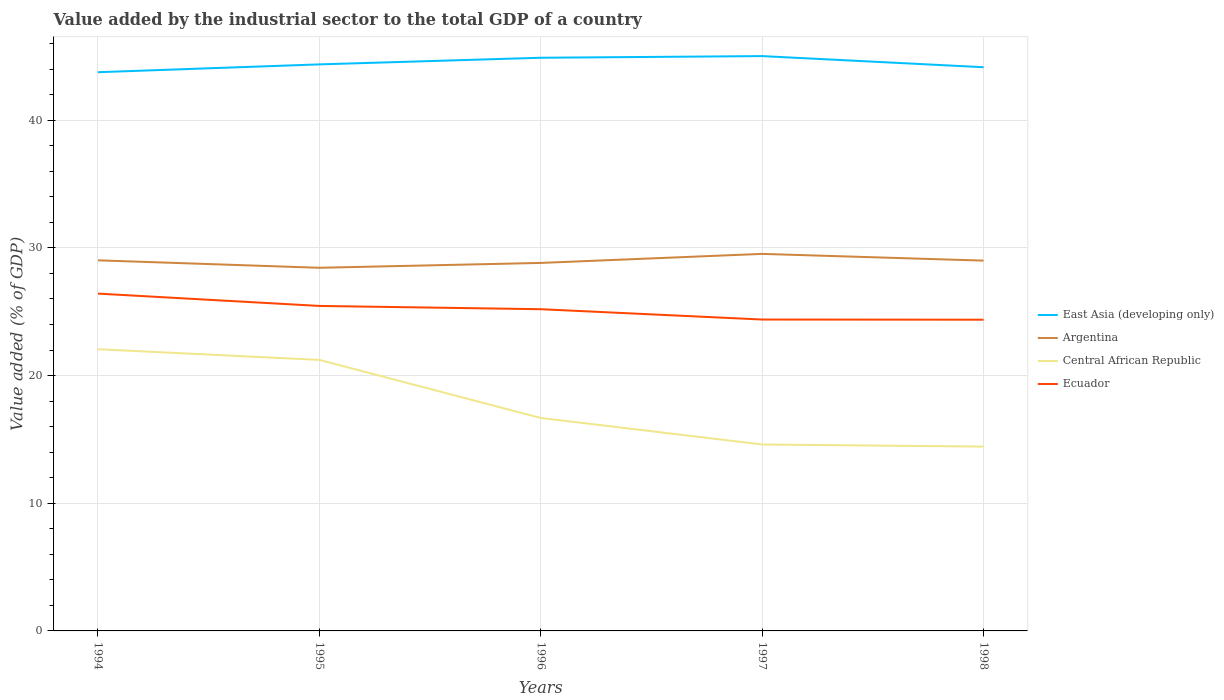Across all years, what is the maximum value added by the industrial sector to the total GDP in Argentina?
Provide a succinct answer. 28.44. In which year was the value added by the industrial sector to the total GDP in Central African Republic maximum?
Offer a terse response. 1998. What is the total value added by the industrial sector to the total GDP in Ecuador in the graph?
Your response must be concise. 1.22. What is the difference between the highest and the second highest value added by the industrial sector to the total GDP in Central African Republic?
Provide a short and direct response. 7.63. What is the difference between the highest and the lowest value added by the industrial sector to the total GDP in Ecuador?
Keep it short and to the point. 3. Does the graph contain grids?
Your response must be concise. Yes. Where does the legend appear in the graph?
Keep it short and to the point. Center right. How many legend labels are there?
Make the answer very short. 4. What is the title of the graph?
Make the answer very short. Value added by the industrial sector to the total GDP of a country. Does "South Sudan" appear as one of the legend labels in the graph?
Your answer should be very brief. No. What is the label or title of the X-axis?
Your response must be concise. Years. What is the label or title of the Y-axis?
Offer a very short reply. Value added (% of GDP). What is the Value added (% of GDP) in East Asia (developing only) in 1994?
Offer a very short reply. 43.76. What is the Value added (% of GDP) of Argentina in 1994?
Give a very brief answer. 29.02. What is the Value added (% of GDP) in Central African Republic in 1994?
Your response must be concise. 22.06. What is the Value added (% of GDP) of Ecuador in 1994?
Provide a short and direct response. 26.42. What is the Value added (% of GDP) in East Asia (developing only) in 1995?
Provide a succinct answer. 44.37. What is the Value added (% of GDP) of Argentina in 1995?
Keep it short and to the point. 28.44. What is the Value added (% of GDP) in Central African Republic in 1995?
Give a very brief answer. 21.23. What is the Value added (% of GDP) in Ecuador in 1995?
Your response must be concise. 25.45. What is the Value added (% of GDP) of East Asia (developing only) in 1996?
Make the answer very short. 44.89. What is the Value added (% of GDP) in Argentina in 1996?
Provide a short and direct response. 28.82. What is the Value added (% of GDP) of Central African Republic in 1996?
Your response must be concise. 16.68. What is the Value added (% of GDP) in Ecuador in 1996?
Your response must be concise. 25.2. What is the Value added (% of GDP) in East Asia (developing only) in 1997?
Offer a very short reply. 45.02. What is the Value added (% of GDP) of Argentina in 1997?
Your answer should be very brief. 29.53. What is the Value added (% of GDP) in Central African Republic in 1997?
Make the answer very short. 14.6. What is the Value added (% of GDP) of Ecuador in 1997?
Offer a terse response. 24.39. What is the Value added (% of GDP) in East Asia (developing only) in 1998?
Provide a succinct answer. 44.15. What is the Value added (% of GDP) in Argentina in 1998?
Your answer should be compact. 29. What is the Value added (% of GDP) in Central African Republic in 1998?
Your response must be concise. 14.44. What is the Value added (% of GDP) of Ecuador in 1998?
Your response must be concise. 24.37. Across all years, what is the maximum Value added (% of GDP) of East Asia (developing only)?
Ensure brevity in your answer.  45.02. Across all years, what is the maximum Value added (% of GDP) of Argentina?
Ensure brevity in your answer.  29.53. Across all years, what is the maximum Value added (% of GDP) in Central African Republic?
Ensure brevity in your answer.  22.06. Across all years, what is the maximum Value added (% of GDP) of Ecuador?
Keep it short and to the point. 26.42. Across all years, what is the minimum Value added (% of GDP) of East Asia (developing only)?
Offer a terse response. 43.76. Across all years, what is the minimum Value added (% of GDP) in Argentina?
Offer a very short reply. 28.44. Across all years, what is the minimum Value added (% of GDP) of Central African Republic?
Offer a very short reply. 14.44. Across all years, what is the minimum Value added (% of GDP) of Ecuador?
Offer a terse response. 24.37. What is the total Value added (% of GDP) in East Asia (developing only) in the graph?
Your answer should be compact. 222.19. What is the total Value added (% of GDP) in Argentina in the graph?
Ensure brevity in your answer.  144.82. What is the total Value added (% of GDP) in Central African Republic in the graph?
Provide a succinct answer. 89.01. What is the total Value added (% of GDP) in Ecuador in the graph?
Your answer should be very brief. 125.83. What is the difference between the Value added (% of GDP) of East Asia (developing only) in 1994 and that in 1995?
Ensure brevity in your answer.  -0.61. What is the difference between the Value added (% of GDP) of Argentina in 1994 and that in 1995?
Your response must be concise. 0.58. What is the difference between the Value added (% of GDP) in Central African Republic in 1994 and that in 1995?
Give a very brief answer. 0.84. What is the difference between the Value added (% of GDP) in Ecuador in 1994 and that in 1995?
Provide a succinct answer. 0.97. What is the difference between the Value added (% of GDP) in East Asia (developing only) in 1994 and that in 1996?
Your answer should be compact. -1.13. What is the difference between the Value added (% of GDP) in Argentina in 1994 and that in 1996?
Give a very brief answer. 0.2. What is the difference between the Value added (% of GDP) of Central African Republic in 1994 and that in 1996?
Your response must be concise. 5.38. What is the difference between the Value added (% of GDP) of Ecuador in 1994 and that in 1996?
Your answer should be very brief. 1.22. What is the difference between the Value added (% of GDP) of East Asia (developing only) in 1994 and that in 1997?
Ensure brevity in your answer.  -1.26. What is the difference between the Value added (% of GDP) in Argentina in 1994 and that in 1997?
Your response must be concise. -0.5. What is the difference between the Value added (% of GDP) of Central African Republic in 1994 and that in 1997?
Offer a terse response. 7.46. What is the difference between the Value added (% of GDP) in Ecuador in 1994 and that in 1997?
Provide a short and direct response. 2.03. What is the difference between the Value added (% of GDP) in East Asia (developing only) in 1994 and that in 1998?
Make the answer very short. -0.39. What is the difference between the Value added (% of GDP) in Argentina in 1994 and that in 1998?
Your answer should be compact. 0.02. What is the difference between the Value added (% of GDP) of Central African Republic in 1994 and that in 1998?
Keep it short and to the point. 7.63. What is the difference between the Value added (% of GDP) of Ecuador in 1994 and that in 1998?
Keep it short and to the point. 2.04. What is the difference between the Value added (% of GDP) in East Asia (developing only) in 1995 and that in 1996?
Offer a terse response. -0.52. What is the difference between the Value added (% of GDP) of Argentina in 1995 and that in 1996?
Your answer should be compact. -0.38. What is the difference between the Value added (% of GDP) of Central African Republic in 1995 and that in 1996?
Your response must be concise. 4.55. What is the difference between the Value added (% of GDP) of Ecuador in 1995 and that in 1996?
Ensure brevity in your answer.  0.26. What is the difference between the Value added (% of GDP) of East Asia (developing only) in 1995 and that in 1997?
Keep it short and to the point. -0.65. What is the difference between the Value added (% of GDP) in Argentina in 1995 and that in 1997?
Offer a terse response. -1.09. What is the difference between the Value added (% of GDP) in Central African Republic in 1995 and that in 1997?
Make the answer very short. 6.62. What is the difference between the Value added (% of GDP) in Ecuador in 1995 and that in 1997?
Your response must be concise. 1.06. What is the difference between the Value added (% of GDP) of East Asia (developing only) in 1995 and that in 1998?
Your response must be concise. 0.22. What is the difference between the Value added (% of GDP) of Argentina in 1995 and that in 1998?
Your answer should be very brief. -0.56. What is the difference between the Value added (% of GDP) in Central African Republic in 1995 and that in 1998?
Ensure brevity in your answer.  6.79. What is the difference between the Value added (% of GDP) in Ecuador in 1995 and that in 1998?
Your answer should be compact. 1.08. What is the difference between the Value added (% of GDP) of East Asia (developing only) in 1996 and that in 1997?
Make the answer very short. -0.13. What is the difference between the Value added (% of GDP) of Argentina in 1996 and that in 1997?
Offer a terse response. -0.71. What is the difference between the Value added (% of GDP) of Central African Republic in 1996 and that in 1997?
Your response must be concise. 2.08. What is the difference between the Value added (% of GDP) of Ecuador in 1996 and that in 1997?
Your answer should be very brief. 0.81. What is the difference between the Value added (% of GDP) in East Asia (developing only) in 1996 and that in 1998?
Give a very brief answer. 0.74. What is the difference between the Value added (% of GDP) of Argentina in 1996 and that in 1998?
Your response must be concise. -0.18. What is the difference between the Value added (% of GDP) of Central African Republic in 1996 and that in 1998?
Your response must be concise. 2.24. What is the difference between the Value added (% of GDP) of Ecuador in 1996 and that in 1998?
Your answer should be compact. 0.82. What is the difference between the Value added (% of GDP) in East Asia (developing only) in 1997 and that in 1998?
Make the answer very short. 0.87. What is the difference between the Value added (% of GDP) in Argentina in 1997 and that in 1998?
Make the answer very short. 0.53. What is the difference between the Value added (% of GDP) in Central African Republic in 1997 and that in 1998?
Ensure brevity in your answer.  0.17. What is the difference between the Value added (% of GDP) in Ecuador in 1997 and that in 1998?
Provide a succinct answer. 0.01. What is the difference between the Value added (% of GDP) in East Asia (developing only) in 1994 and the Value added (% of GDP) in Argentina in 1995?
Offer a very short reply. 15.32. What is the difference between the Value added (% of GDP) of East Asia (developing only) in 1994 and the Value added (% of GDP) of Central African Republic in 1995?
Give a very brief answer. 22.53. What is the difference between the Value added (% of GDP) in East Asia (developing only) in 1994 and the Value added (% of GDP) in Ecuador in 1995?
Give a very brief answer. 18.31. What is the difference between the Value added (% of GDP) of Argentina in 1994 and the Value added (% of GDP) of Central African Republic in 1995?
Provide a succinct answer. 7.8. What is the difference between the Value added (% of GDP) of Argentina in 1994 and the Value added (% of GDP) of Ecuador in 1995?
Offer a very short reply. 3.57. What is the difference between the Value added (% of GDP) of Central African Republic in 1994 and the Value added (% of GDP) of Ecuador in 1995?
Ensure brevity in your answer.  -3.39. What is the difference between the Value added (% of GDP) of East Asia (developing only) in 1994 and the Value added (% of GDP) of Argentina in 1996?
Offer a very short reply. 14.94. What is the difference between the Value added (% of GDP) in East Asia (developing only) in 1994 and the Value added (% of GDP) in Central African Republic in 1996?
Offer a very short reply. 27.08. What is the difference between the Value added (% of GDP) in East Asia (developing only) in 1994 and the Value added (% of GDP) in Ecuador in 1996?
Provide a succinct answer. 18.56. What is the difference between the Value added (% of GDP) of Argentina in 1994 and the Value added (% of GDP) of Central African Republic in 1996?
Provide a short and direct response. 12.35. What is the difference between the Value added (% of GDP) of Argentina in 1994 and the Value added (% of GDP) of Ecuador in 1996?
Provide a succinct answer. 3.83. What is the difference between the Value added (% of GDP) in Central African Republic in 1994 and the Value added (% of GDP) in Ecuador in 1996?
Ensure brevity in your answer.  -3.13. What is the difference between the Value added (% of GDP) of East Asia (developing only) in 1994 and the Value added (% of GDP) of Argentina in 1997?
Your response must be concise. 14.23. What is the difference between the Value added (% of GDP) of East Asia (developing only) in 1994 and the Value added (% of GDP) of Central African Republic in 1997?
Offer a very short reply. 29.16. What is the difference between the Value added (% of GDP) in East Asia (developing only) in 1994 and the Value added (% of GDP) in Ecuador in 1997?
Your response must be concise. 19.37. What is the difference between the Value added (% of GDP) of Argentina in 1994 and the Value added (% of GDP) of Central African Republic in 1997?
Ensure brevity in your answer.  14.42. What is the difference between the Value added (% of GDP) of Argentina in 1994 and the Value added (% of GDP) of Ecuador in 1997?
Make the answer very short. 4.64. What is the difference between the Value added (% of GDP) of Central African Republic in 1994 and the Value added (% of GDP) of Ecuador in 1997?
Your answer should be very brief. -2.33. What is the difference between the Value added (% of GDP) of East Asia (developing only) in 1994 and the Value added (% of GDP) of Argentina in 1998?
Give a very brief answer. 14.76. What is the difference between the Value added (% of GDP) in East Asia (developing only) in 1994 and the Value added (% of GDP) in Central African Republic in 1998?
Your response must be concise. 29.32. What is the difference between the Value added (% of GDP) in East Asia (developing only) in 1994 and the Value added (% of GDP) in Ecuador in 1998?
Give a very brief answer. 19.38. What is the difference between the Value added (% of GDP) in Argentina in 1994 and the Value added (% of GDP) in Central African Republic in 1998?
Ensure brevity in your answer.  14.59. What is the difference between the Value added (% of GDP) in Argentina in 1994 and the Value added (% of GDP) in Ecuador in 1998?
Provide a short and direct response. 4.65. What is the difference between the Value added (% of GDP) in Central African Republic in 1994 and the Value added (% of GDP) in Ecuador in 1998?
Offer a very short reply. -2.31. What is the difference between the Value added (% of GDP) in East Asia (developing only) in 1995 and the Value added (% of GDP) in Argentina in 1996?
Keep it short and to the point. 15.55. What is the difference between the Value added (% of GDP) of East Asia (developing only) in 1995 and the Value added (% of GDP) of Central African Republic in 1996?
Ensure brevity in your answer.  27.69. What is the difference between the Value added (% of GDP) of East Asia (developing only) in 1995 and the Value added (% of GDP) of Ecuador in 1996?
Ensure brevity in your answer.  19.17. What is the difference between the Value added (% of GDP) of Argentina in 1995 and the Value added (% of GDP) of Central African Republic in 1996?
Provide a short and direct response. 11.76. What is the difference between the Value added (% of GDP) of Argentina in 1995 and the Value added (% of GDP) of Ecuador in 1996?
Give a very brief answer. 3.24. What is the difference between the Value added (% of GDP) in Central African Republic in 1995 and the Value added (% of GDP) in Ecuador in 1996?
Make the answer very short. -3.97. What is the difference between the Value added (% of GDP) in East Asia (developing only) in 1995 and the Value added (% of GDP) in Argentina in 1997?
Ensure brevity in your answer.  14.84. What is the difference between the Value added (% of GDP) of East Asia (developing only) in 1995 and the Value added (% of GDP) of Central African Republic in 1997?
Your answer should be very brief. 29.77. What is the difference between the Value added (% of GDP) in East Asia (developing only) in 1995 and the Value added (% of GDP) in Ecuador in 1997?
Make the answer very short. 19.98. What is the difference between the Value added (% of GDP) in Argentina in 1995 and the Value added (% of GDP) in Central African Republic in 1997?
Your answer should be very brief. 13.84. What is the difference between the Value added (% of GDP) of Argentina in 1995 and the Value added (% of GDP) of Ecuador in 1997?
Provide a short and direct response. 4.05. What is the difference between the Value added (% of GDP) in Central African Republic in 1995 and the Value added (% of GDP) in Ecuador in 1997?
Your answer should be very brief. -3.16. What is the difference between the Value added (% of GDP) of East Asia (developing only) in 1995 and the Value added (% of GDP) of Argentina in 1998?
Offer a terse response. 15.37. What is the difference between the Value added (% of GDP) in East Asia (developing only) in 1995 and the Value added (% of GDP) in Central African Republic in 1998?
Give a very brief answer. 29.93. What is the difference between the Value added (% of GDP) in East Asia (developing only) in 1995 and the Value added (% of GDP) in Ecuador in 1998?
Your answer should be very brief. 20. What is the difference between the Value added (% of GDP) in Argentina in 1995 and the Value added (% of GDP) in Central African Republic in 1998?
Provide a succinct answer. 14. What is the difference between the Value added (% of GDP) of Argentina in 1995 and the Value added (% of GDP) of Ecuador in 1998?
Offer a terse response. 4.07. What is the difference between the Value added (% of GDP) in Central African Republic in 1995 and the Value added (% of GDP) in Ecuador in 1998?
Your answer should be compact. -3.15. What is the difference between the Value added (% of GDP) in East Asia (developing only) in 1996 and the Value added (% of GDP) in Argentina in 1997?
Your answer should be compact. 15.36. What is the difference between the Value added (% of GDP) in East Asia (developing only) in 1996 and the Value added (% of GDP) in Central African Republic in 1997?
Offer a very short reply. 30.29. What is the difference between the Value added (% of GDP) of East Asia (developing only) in 1996 and the Value added (% of GDP) of Ecuador in 1997?
Give a very brief answer. 20.5. What is the difference between the Value added (% of GDP) of Argentina in 1996 and the Value added (% of GDP) of Central African Republic in 1997?
Your answer should be very brief. 14.22. What is the difference between the Value added (% of GDP) in Argentina in 1996 and the Value added (% of GDP) in Ecuador in 1997?
Ensure brevity in your answer.  4.43. What is the difference between the Value added (% of GDP) in Central African Republic in 1996 and the Value added (% of GDP) in Ecuador in 1997?
Your answer should be very brief. -7.71. What is the difference between the Value added (% of GDP) of East Asia (developing only) in 1996 and the Value added (% of GDP) of Argentina in 1998?
Provide a succinct answer. 15.89. What is the difference between the Value added (% of GDP) in East Asia (developing only) in 1996 and the Value added (% of GDP) in Central African Republic in 1998?
Your answer should be compact. 30.45. What is the difference between the Value added (% of GDP) in East Asia (developing only) in 1996 and the Value added (% of GDP) in Ecuador in 1998?
Ensure brevity in your answer.  20.52. What is the difference between the Value added (% of GDP) of Argentina in 1996 and the Value added (% of GDP) of Central African Republic in 1998?
Offer a terse response. 14.38. What is the difference between the Value added (% of GDP) in Argentina in 1996 and the Value added (% of GDP) in Ecuador in 1998?
Provide a succinct answer. 4.45. What is the difference between the Value added (% of GDP) of Central African Republic in 1996 and the Value added (% of GDP) of Ecuador in 1998?
Your answer should be very brief. -7.7. What is the difference between the Value added (% of GDP) in East Asia (developing only) in 1997 and the Value added (% of GDP) in Argentina in 1998?
Provide a short and direct response. 16.02. What is the difference between the Value added (% of GDP) of East Asia (developing only) in 1997 and the Value added (% of GDP) of Central African Republic in 1998?
Your response must be concise. 30.58. What is the difference between the Value added (% of GDP) in East Asia (developing only) in 1997 and the Value added (% of GDP) in Ecuador in 1998?
Give a very brief answer. 20.65. What is the difference between the Value added (% of GDP) in Argentina in 1997 and the Value added (% of GDP) in Central African Republic in 1998?
Provide a succinct answer. 15.09. What is the difference between the Value added (% of GDP) of Argentina in 1997 and the Value added (% of GDP) of Ecuador in 1998?
Your answer should be compact. 5.15. What is the difference between the Value added (% of GDP) in Central African Republic in 1997 and the Value added (% of GDP) in Ecuador in 1998?
Your answer should be very brief. -9.77. What is the average Value added (% of GDP) in East Asia (developing only) per year?
Provide a short and direct response. 44.44. What is the average Value added (% of GDP) of Argentina per year?
Ensure brevity in your answer.  28.96. What is the average Value added (% of GDP) in Central African Republic per year?
Offer a very short reply. 17.8. What is the average Value added (% of GDP) in Ecuador per year?
Offer a very short reply. 25.17. In the year 1994, what is the difference between the Value added (% of GDP) in East Asia (developing only) and Value added (% of GDP) in Argentina?
Ensure brevity in your answer.  14.73. In the year 1994, what is the difference between the Value added (% of GDP) in East Asia (developing only) and Value added (% of GDP) in Central African Republic?
Your answer should be very brief. 21.7. In the year 1994, what is the difference between the Value added (% of GDP) of East Asia (developing only) and Value added (% of GDP) of Ecuador?
Make the answer very short. 17.34. In the year 1994, what is the difference between the Value added (% of GDP) in Argentina and Value added (% of GDP) in Central African Republic?
Ensure brevity in your answer.  6.96. In the year 1994, what is the difference between the Value added (% of GDP) in Argentina and Value added (% of GDP) in Ecuador?
Provide a succinct answer. 2.61. In the year 1994, what is the difference between the Value added (% of GDP) of Central African Republic and Value added (% of GDP) of Ecuador?
Offer a terse response. -4.36. In the year 1995, what is the difference between the Value added (% of GDP) in East Asia (developing only) and Value added (% of GDP) in Argentina?
Offer a very short reply. 15.93. In the year 1995, what is the difference between the Value added (% of GDP) of East Asia (developing only) and Value added (% of GDP) of Central African Republic?
Your answer should be compact. 23.15. In the year 1995, what is the difference between the Value added (% of GDP) in East Asia (developing only) and Value added (% of GDP) in Ecuador?
Your answer should be very brief. 18.92. In the year 1995, what is the difference between the Value added (% of GDP) in Argentina and Value added (% of GDP) in Central African Republic?
Your answer should be compact. 7.22. In the year 1995, what is the difference between the Value added (% of GDP) in Argentina and Value added (% of GDP) in Ecuador?
Your response must be concise. 2.99. In the year 1995, what is the difference between the Value added (% of GDP) in Central African Republic and Value added (% of GDP) in Ecuador?
Keep it short and to the point. -4.23. In the year 1996, what is the difference between the Value added (% of GDP) of East Asia (developing only) and Value added (% of GDP) of Argentina?
Provide a short and direct response. 16.07. In the year 1996, what is the difference between the Value added (% of GDP) in East Asia (developing only) and Value added (% of GDP) in Central African Republic?
Ensure brevity in your answer.  28.21. In the year 1996, what is the difference between the Value added (% of GDP) of East Asia (developing only) and Value added (% of GDP) of Ecuador?
Your response must be concise. 19.69. In the year 1996, what is the difference between the Value added (% of GDP) of Argentina and Value added (% of GDP) of Central African Republic?
Your answer should be compact. 12.14. In the year 1996, what is the difference between the Value added (% of GDP) in Argentina and Value added (% of GDP) in Ecuador?
Your answer should be very brief. 3.63. In the year 1996, what is the difference between the Value added (% of GDP) of Central African Republic and Value added (% of GDP) of Ecuador?
Offer a terse response. -8.52. In the year 1997, what is the difference between the Value added (% of GDP) in East Asia (developing only) and Value added (% of GDP) in Argentina?
Offer a terse response. 15.49. In the year 1997, what is the difference between the Value added (% of GDP) of East Asia (developing only) and Value added (% of GDP) of Central African Republic?
Provide a succinct answer. 30.42. In the year 1997, what is the difference between the Value added (% of GDP) in East Asia (developing only) and Value added (% of GDP) in Ecuador?
Make the answer very short. 20.63. In the year 1997, what is the difference between the Value added (% of GDP) in Argentina and Value added (% of GDP) in Central African Republic?
Ensure brevity in your answer.  14.93. In the year 1997, what is the difference between the Value added (% of GDP) in Argentina and Value added (% of GDP) in Ecuador?
Your answer should be compact. 5.14. In the year 1997, what is the difference between the Value added (% of GDP) of Central African Republic and Value added (% of GDP) of Ecuador?
Your answer should be compact. -9.79. In the year 1998, what is the difference between the Value added (% of GDP) in East Asia (developing only) and Value added (% of GDP) in Argentina?
Offer a terse response. 15.15. In the year 1998, what is the difference between the Value added (% of GDP) in East Asia (developing only) and Value added (% of GDP) in Central African Republic?
Your answer should be compact. 29.71. In the year 1998, what is the difference between the Value added (% of GDP) in East Asia (developing only) and Value added (% of GDP) in Ecuador?
Your answer should be compact. 19.77. In the year 1998, what is the difference between the Value added (% of GDP) in Argentina and Value added (% of GDP) in Central African Republic?
Your answer should be very brief. 14.56. In the year 1998, what is the difference between the Value added (% of GDP) of Argentina and Value added (% of GDP) of Ecuador?
Your answer should be very brief. 4.63. In the year 1998, what is the difference between the Value added (% of GDP) of Central African Republic and Value added (% of GDP) of Ecuador?
Ensure brevity in your answer.  -9.94. What is the ratio of the Value added (% of GDP) in East Asia (developing only) in 1994 to that in 1995?
Provide a short and direct response. 0.99. What is the ratio of the Value added (% of GDP) in Argentina in 1994 to that in 1995?
Make the answer very short. 1.02. What is the ratio of the Value added (% of GDP) of Central African Republic in 1994 to that in 1995?
Your answer should be compact. 1.04. What is the ratio of the Value added (% of GDP) in Ecuador in 1994 to that in 1995?
Make the answer very short. 1.04. What is the ratio of the Value added (% of GDP) of East Asia (developing only) in 1994 to that in 1996?
Offer a terse response. 0.97. What is the ratio of the Value added (% of GDP) in Central African Republic in 1994 to that in 1996?
Make the answer very short. 1.32. What is the ratio of the Value added (% of GDP) in Ecuador in 1994 to that in 1996?
Ensure brevity in your answer.  1.05. What is the ratio of the Value added (% of GDP) of East Asia (developing only) in 1994 to that in 1997?
Your answer should be very brief. 0.97. What is the ratio of the Value added (% of GDP) in Argentina in 1994 to that in 1997?
Make the answer very short. 0.98. What is the ratio of the Value added (% of GDP) of Central African Republic in 1994 to that in 1997?
Offer a very short reply. 1.51. What is the ratio of the Value added (% of GDP) of Argentina in 1994 to that in 1998?
Provide a succinct answer. 1. What is the ratio of the Value added (% of GDP) of Central African Republic in 1994 to that in 1998?
Offer a very short reply. 1.53. What is the ratio of the Value added (% of GDP) in Ecuador in 1994 to that in 1998?
Your response must be concise. 1.08. What is the ratio of the Value added (% of GDP) in East Asia (developing only) in 1995 to that in 1996?
Offer a terse response. 0.99. What is the ratio of the Value added (% of GDP) of Argentina in 1995 to that in 1996?
Provide a succinct answer. 0.99. What is the ratio of the Value added (% of GDP) in Central African Republic in 1995 to that in 1996?
Provide a succinct answer. 1.27. What is the ratio of the Value added (% of GDP) in Ecuador in 1995 to that in 1996?
Keep it short and to the point. 1.01. What is the ratio of the Value added (% of GDP) of East Asia (developing only) in 1995 to that in 1997?
Make the answer very short. 0.99. What is the ratio of the Value added (% of GDP) of Argentina in 1995 to that in 1997?
Ensure brevity in your answer.  0.96. What is the ratio of the Value added (% of GDP) of Central African Republic in 1995 to that in 1997?
Make the answer very short. 1.45. What is the ratio of the Value added (% of GDP) of Ecuador in 1995 to that in 1997?
Offer a terse response. 1.04. What is the ratio of the Value added (% of GDP) of East Asia (developing only) in 1995 to that in 1998?
Give a very brief answer. 1. What is the ratio of the Value added (% of GDP) of Argentina in 1995 to that in 1998?
Give a very brief answer. 0.98. What is the ratio of the Value added (% of GDP) in Central African Republic in 1995 to that in 1998?
Make the answer very short. 1.47. What is the ratio of the Value added (% of GDP) of Ecuador in 1995 to that in 1998?
Your answer should be very brief. 1.04. What is the ratio of the Value added (% of GDP) of East Asia (developing only) in 1996 to that in 1997?
Ensure brevity in your answer.  1. What is the ratio of the Value added (% of GDP) of Argentina in 1996 to that in 1997?
Offer a terse response. 0.98. What is the ratio of the Value added (% of GDP) of Central African Republic in 1996 to that in 1997?
Keep it short and to the point. 1.14. What is the ratio of the Value added (% of GDP) in Ecuador in 1996 to that in 1997?
Your answer should be very brief. 1.03. What is the ratio of the Value added (% of GDP) of East Asia (developing only) in 1996 to that in 1998?
Make the answer very short. 1.02. What is the ratio of the Value added (% of GDP) in Argentina in 1996 to that in 1998?
Ensure brevity in your answer.  0.99. What is the ratio of the Value added (% of GDP) in Central African Republic in 1996 to that in 1998?
Ensure brevity in your answer.  1.16. What is the ratio of the Value added (% of GDP) of Ecuador in 1996 to that in 1998?
Keep it short and to the point. 1.03. What is the ratio of the Value added (% of GDP) in East Asia (developing only) in 1997 to that in 1998?
Your answer should be compact. 1.02. What is the ratio of the Value added (% of GDP) in Argentina in 1997 to that in 1998?
Ensure brevity in your answer.  1.02. What is the ratio of the Value added (% of GDP) in Central African Republic in 1997 to that in 1998?
Provide a short and direct response. 1.01. What is the ratio of the Value added (% of GDP) of Ecuador in 1997 to that in 1998?
Provide a short and direct response. 1. What is the difference between the highest and the second highest Value added (% of GDP) of East Asia (developing only)?
Make the answer very short. 0.13. What is the difference between the highest and the second highest Value added (% of GDP) in Argentina?
Provide a short and direct response. 0.5. What is the difference between the highest and the second highest Value added (% of GDP) in Central African Republic?
Provide a short and direct response. 0.84. What is the difference between the highest and the second highest Value added (% of GDP) of Ecuador?
Provide a succinct answer. 0.97. What is the difference between the highest and the lowest Value added (% of GDP) of East Asia (developing only)?
Offer a very short reply. 1.26. What is the difference between the highest and the lowest Value added (% of GDP) of Argentina?
Make the answer very short. 1.09. What is the difference between the highest and the lowest Value added (% of GDP) of Central African Republic?
Provide a short and direct response. 7.63. What is the difference between the highest and the lowest Value added (% of GDP) of Ecuador?
Offer a terse response. 2.04. 